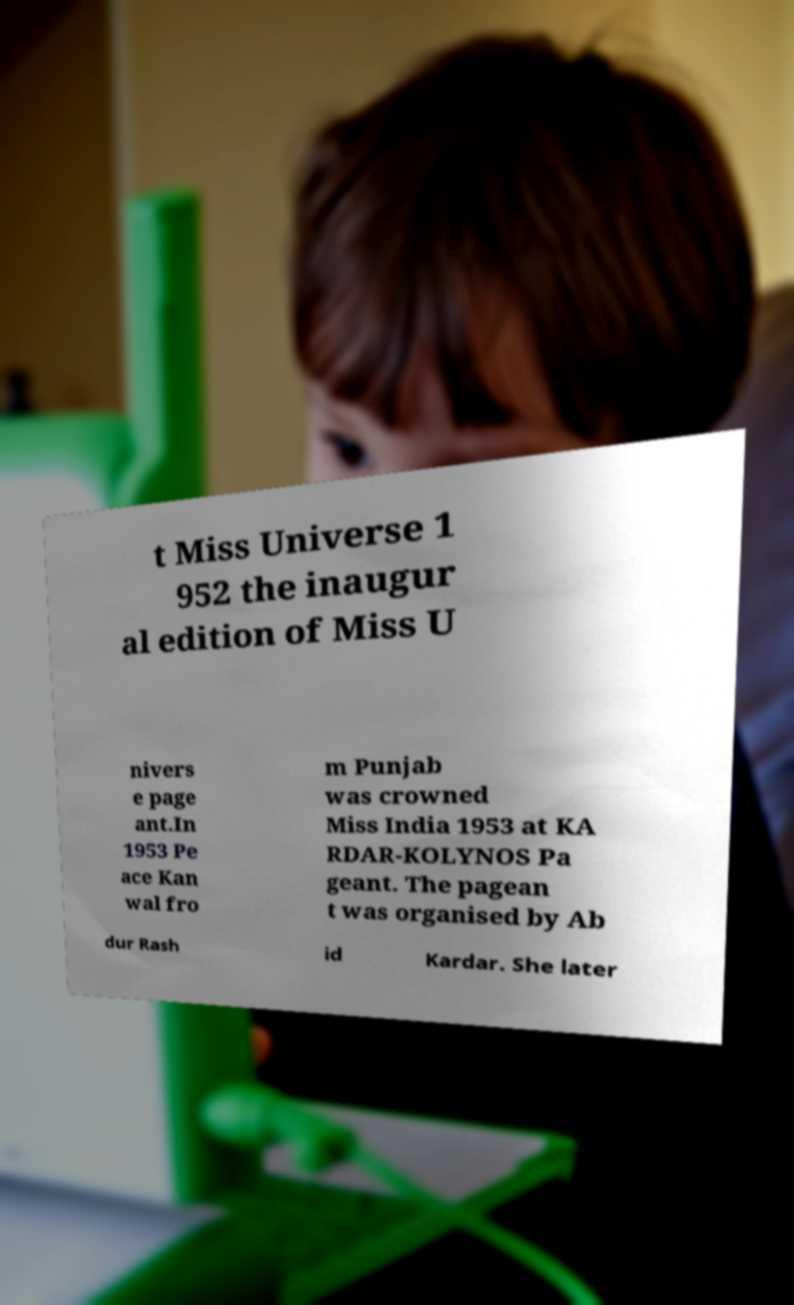Could you extract and type out the text from this image? t Miss Universe 1 952 the inaugur al edition of Miss U nivers e page ant.In 1953 Pe ace Kan wal fro m Punjab was crowned Miss India 1953 at KA RDAR-KOLYNOS Pa geant. The pagean t was organised by Ab dur Rash id Kardar. She later 